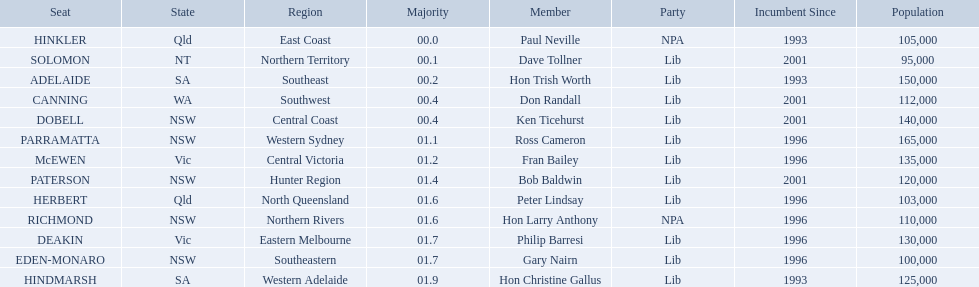How many states were represented in the seats? 6. Help me parse the entirety of this table. {'header': ['Seat', 'State', 'Region', 'Majority', 'Member', 'Party', 'Incumbent Since', 'Population'], 'rows': [['HINKLER', 'Qld', 'East Coast', '00.0', 'Paul Neville', 'NPA', '1993', '105,000'], ['SOLOMON', 'NT', 'Northern Territory', '00.1', 'Dave Tollner', 'Lib', '2001', '95,000'], ['ADELAIDE', 'SA', 'Southeast', '00.2', 'Hon Trish Worth', 'Lib', '1993', '150,000'], ['CANNING', 'WA', 'Southwest', '00.4', 'Don Randall', 'Lib', '2001', '112,000'], ['DOBELL', 'NSW', 'Central Coast', '00.4', 'Ken Ticehurst', 'Lib', '2001', '140,000'], ['PARRAMATTA', 'NSW', 'Western Sydney', '01.1', 'Ross Cameron', 'Lib', '1996', '165,000'], ['McEWEN', 'Vic', 'Central Victoria', '01.2', 'Fran Bailey', 'Lib', '1996', '135,000'], ['PATERSON', 'NSW', 'Hunter Region', '01.4', 'Bob Baldwin', 'Lib', '2001', '120,000'], ['HERBERT', 'Qld', 'North Queensland', '01.6', 'Peter Lindsay', 'Lib', '1996', '103,000'], ['RICHMOND', 'NSW', 'Northern Rivers', '01.6', 'Hon Larry Anthony', 'NPA', '1996', '110,000'], ['DEAKIN', 'Vic', 'Eastern Melbourne', '01.7', 'Philip Barresi', 'Lib', '1996', '130,000'], ['EDEN-MONARO', 'NSW', 'Southeastern', '01.7', 'Gary Nairn', 'Lib', '1996', '100,000'], ['HINDMARSH', 'SA', 'Western Adelaide', '01.9', 'Hon Christine Gallus', 'Lib', '1993', '125,000']]} 